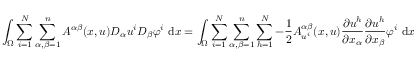Convert formula to latex. <formula><loc_0><loc_0><loc_500><loc_500>\int _ { \Omega } \sum _ { i = 1 } ^ { N } \sum _ { \alpha , \beta = 1 } ^ { n } A ^ { \alpha \beta } ( x , u ) D _ { \alpha } u ^ { i } D _ { \beta } \varphi ^ { i } \ d x = \int _ { \Omega } \sum _ { i = 1 } ^ { N } \sum _ { \alpha , \beta = 1 } ^ { n } \sum _ { h = 1 } ^ { N } - \frac { 1 } { 2 } A _ { u ^ { i } } ^ { \alpha \beta } ( x , u ) \frac { \partial u ^ { h } } { \partial x _ { \alpha } } \frac { \partial u ^ { h } } { \partial x _ { \beta } } \varphi ^ { i } \ d x</formula> 